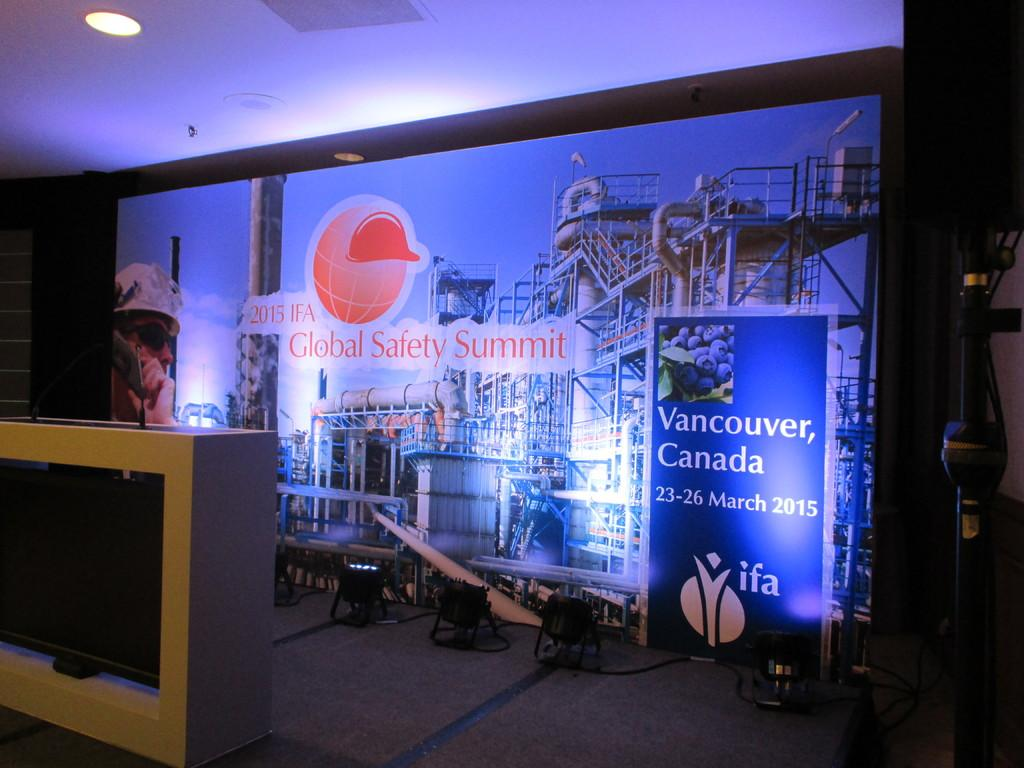Provide a one-sentence caption for the provided image. The stage for the 2015 Global Safety Summit in Canada. 